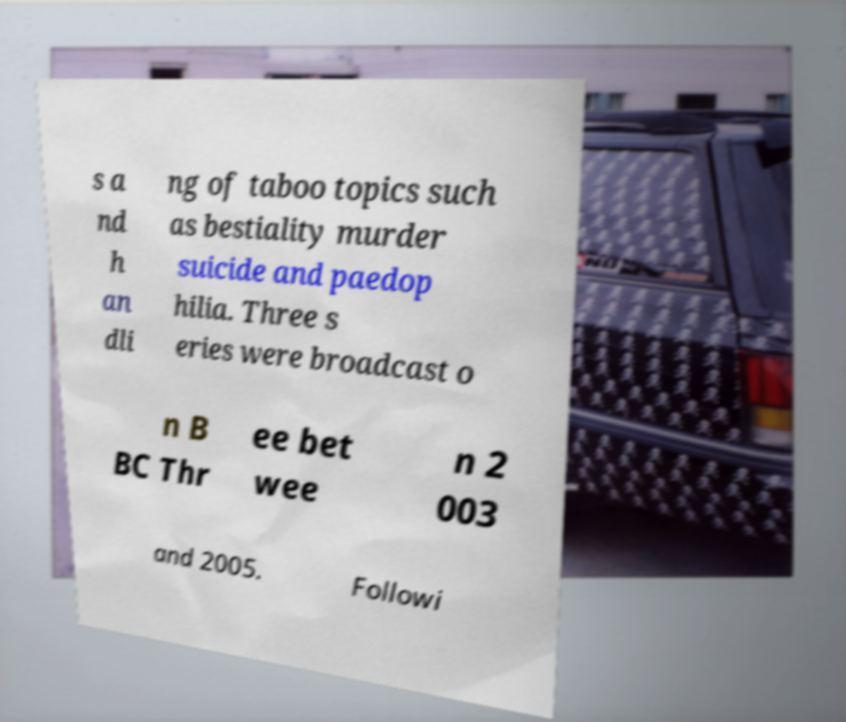Please read and relay the text visible in this image. What does it say? s a nd h an dli ng of taboo topics such as bestiality murder suicide and paedop hilia. Three s eries were broadcast o n B BC Thr ee bet wee n 2 003 and 2005. Followi 